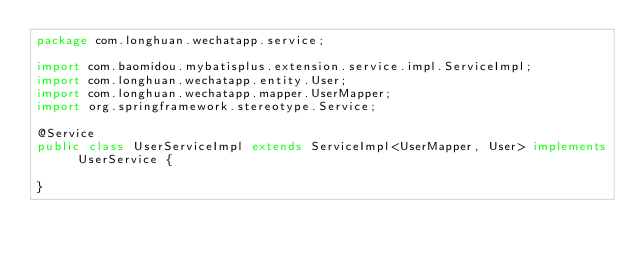Convert code to text. <code><loc_0><loc_0><loc_500><loc_500><_Java_>package com.longhuan.wechatapp.service;

import com.baomidou.mybatisplus.extension.service.impl.ServiceImpl;
import com.longhuan.wechatapp.entity.User;
import com.longhuan.wechatapp.mapper.UserMapper;
import org.springframework.stereotype.Service;

@Service
public class UserServiceImpl extends ServiceImpl<UserMapper, User> implements UserService {

}
</code> 